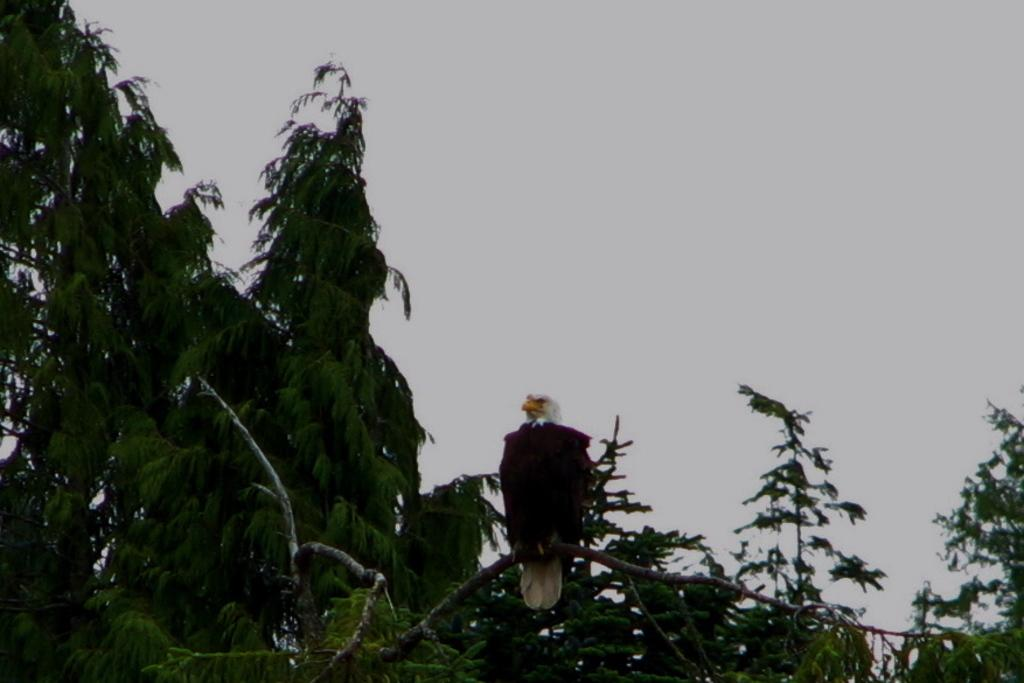What is the main subject of the image? There is a bird in the center of the image. Where is the bird located in relation to the stem? The bird is on a stem. What can be seen in the background of the image? There are trees in the background of the image. What is visible at the top of the image? The sky is visible at the top of the image. What type of bomb can be seen in the image? There is no bomb present in the image; it features a bird on a stem with trees and sky in the background. What is the bird's mom doing in the image? There is no indication of the bird's mom in the image, as it only shows the bird on a stem. 